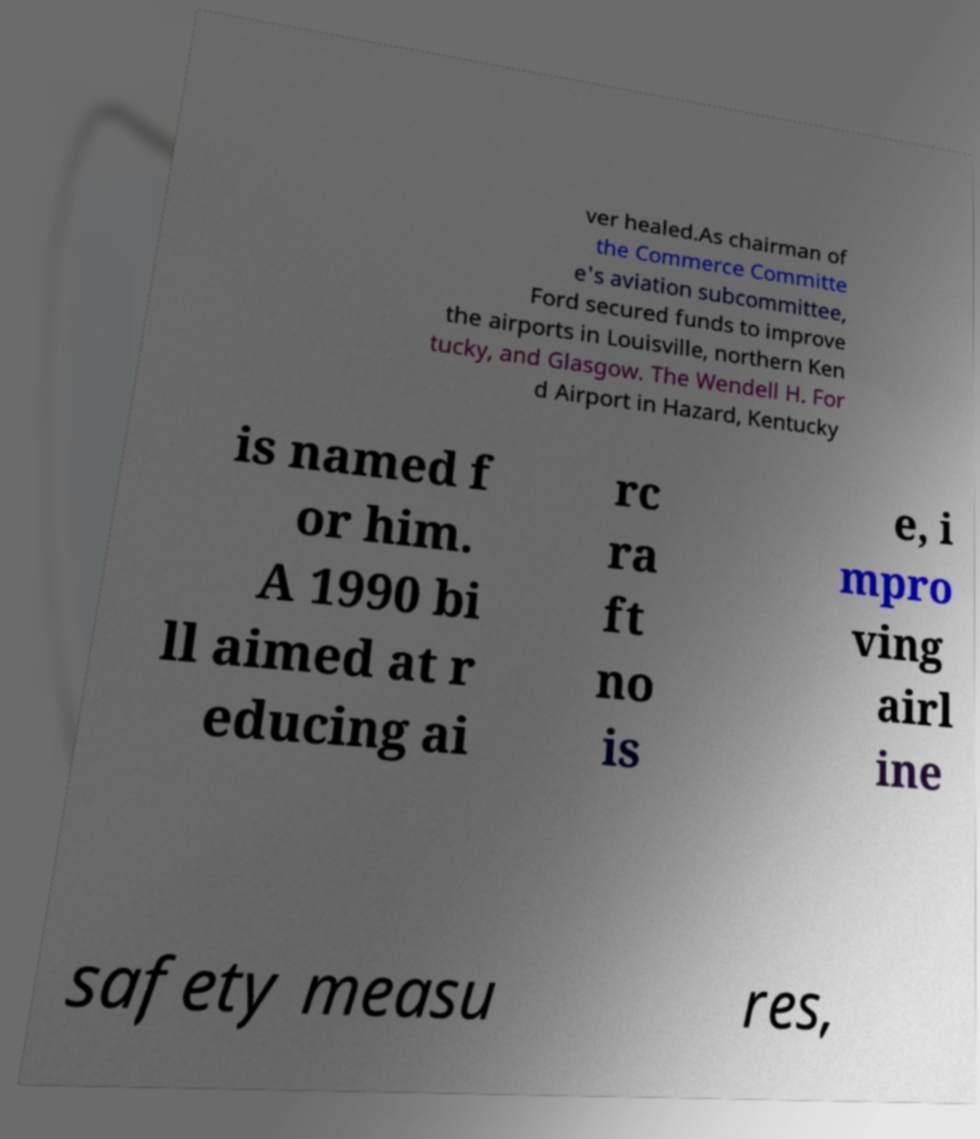Please identify and transcribe the text found in this image. ver healed.As chairman of the Commerce Committe e's aviation subcommittee, Ford secured funds to improve the airports in Louisville, northern Ken tucky, and Glasgow. The Wendell H. For d Airport in Hazard, Kentucky is named f or him. A 1990 bi ll aimed at r educing ai rc ra ft no is e, i mpro ving airl ine safety measu res, 